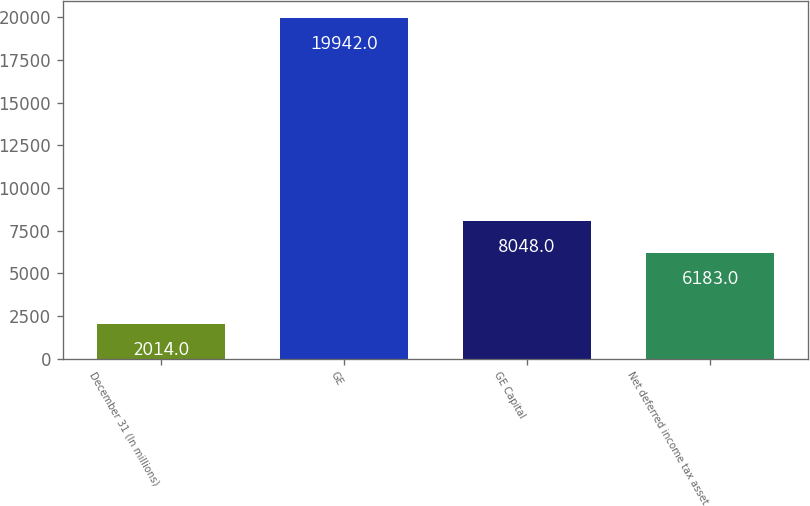<chart> <loc_0><loc_0><loc_500><loc_500><bar_chart><fcel>December 31 (In millions)<fcel>GE<fcel>GE Capital<fcel>Net deferred income tax asset<nl><fcel>2014<fcel>19942<fcel>8048<fcel>6183<nl></chart> 